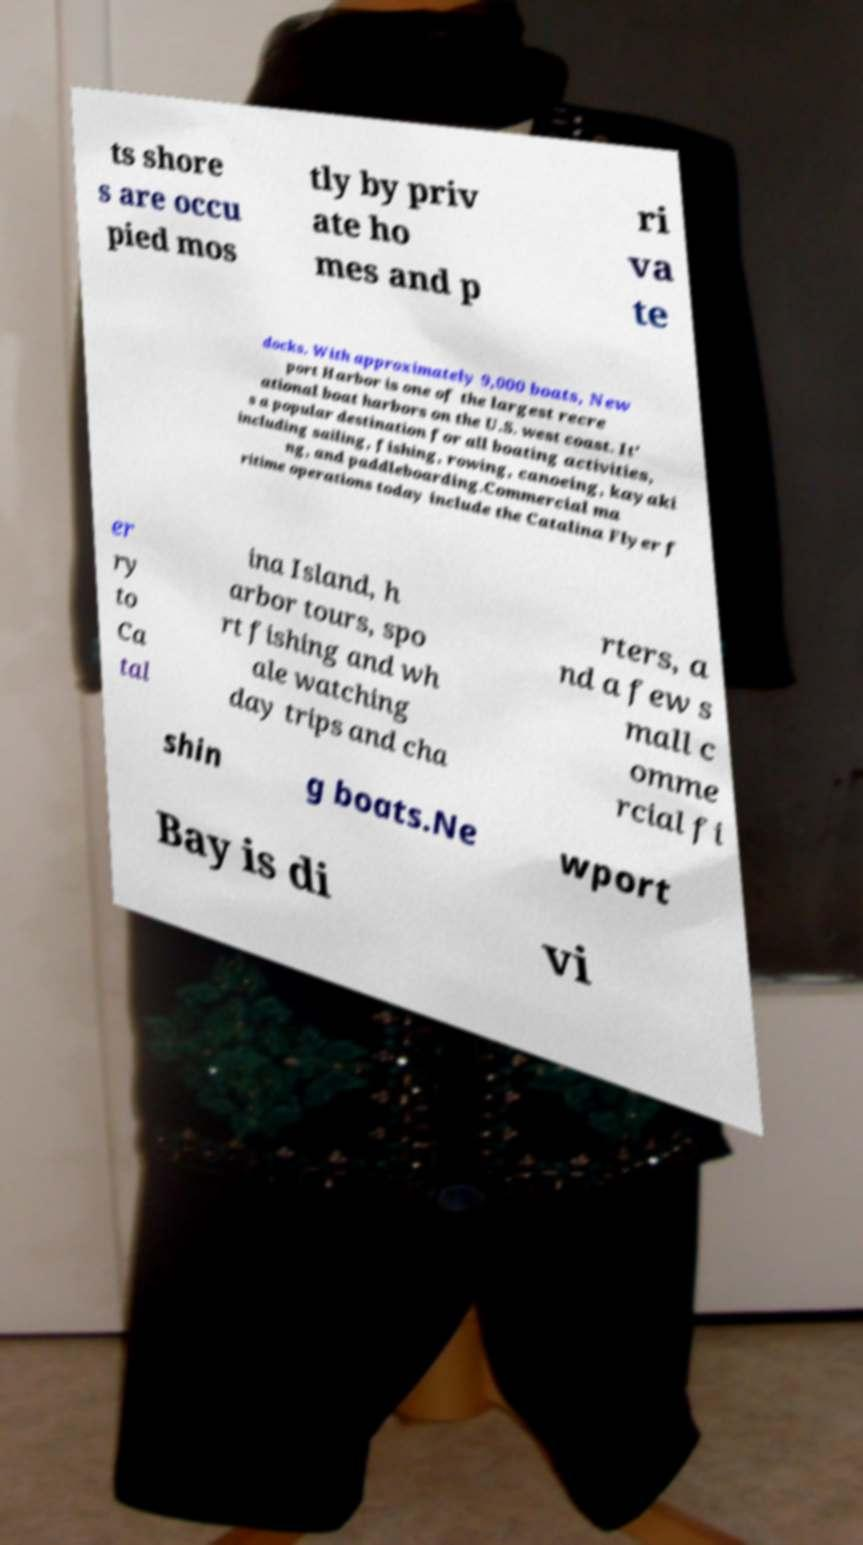Could you extract and type out the text from this image? ts shore s are occu pied mos tly by priv ate ho mes and p ri va te docks. With approximately 9,000 boats, New port Harbor is one of the largest recre ational boat harbors on the U.S. west coast. It' s a popular destination for all boating activities, including sailing, fishing, rowing, canoeing, kayaki ng, and paddleboarding.Commercial ma ritime operations today include the Catalina Flyer f er ry to Ca tal ina Island, h arbor tours, spo rt fishing and wh ale watching day trips and cha rters, a nd a few s mall c omme rcial fi shin g boats.Ne wport Bay is di vi 